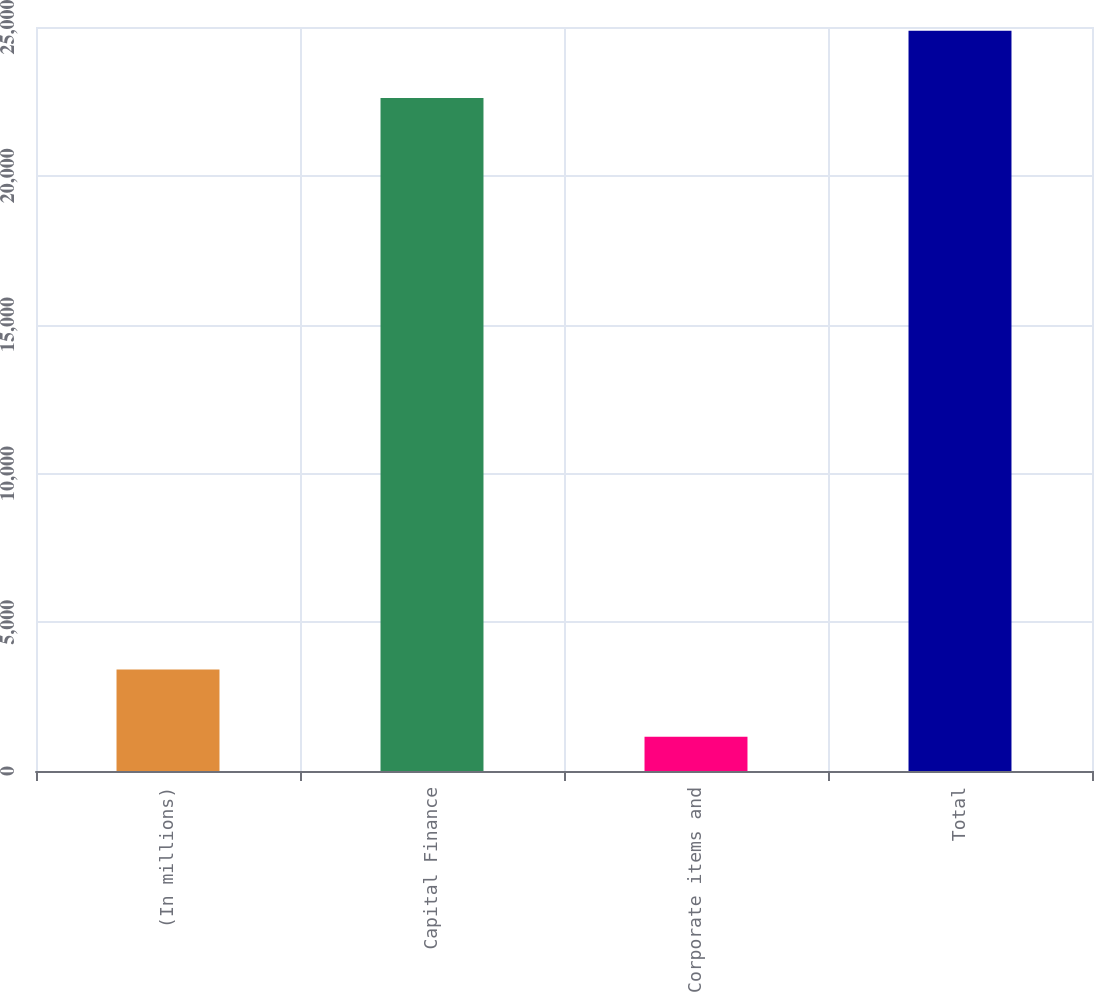Convert chart to OTSL. <chart><loc_0><loc_0><loc_500><loc_500><bar_chart><fcel>(In millions)<fcel>Capital Finance<fcel>Corporate items and<fcel>Total<nl><fcel>3412.1<fcel>22611<fcel>1151<fcel>24872.1<nl></chart> 